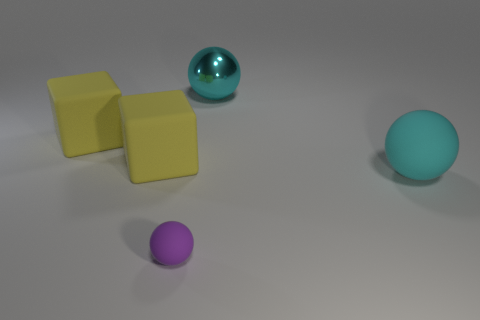Is the color of the big shiny ball the same as the big rubber object that is right of the small purple thing?
Ensure brevity in your answer.  Yes. What is the material of the large object that is the same color as the big matte ball?
Your answer should be very brief. Metal. How many objects are either small blue rubber balls or objects behind the small purple ball?
Make the answer very short. 4. Are there fewer purple matte spheres that are to the left of the purple rubber thing than large yellow rubber things that are behind the big cyan matte object?
Offer a very short reply. Yes. What number of other things are the same material as the purple thing?
Your answer should be very brief. 3. There is a rubber thing that is on the right side of the tiny purple matte thing; is its color the same as the large metallic thing?
Keep it short and to the point. Yes. There is a large sphere behind the cyan matte sphere; is there a purple matte thing that is in front of it?
Your answer should be compact. Yes. The ball that is both in front of the large cyan metal sphere and behind the small purple sphere is made of what material?
Keep it short and to the point. Rubber. There is a cyan thing that is the same material as the small ball; what shape is it?
Offer a terse response. Sphere. Is the material of the large ball that is in front of the large metallic sphere the same as the purple object?
Your response must be concise. Yes. 